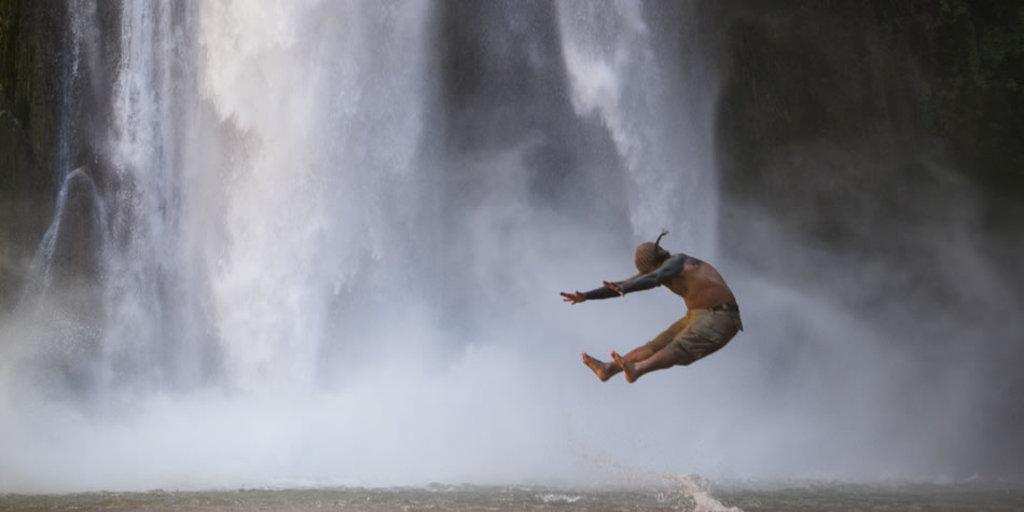What is happening to the person in the image? The person is in the air in the image. What can be seen in the background of the image? There is water visible in the background of the image. What type of worm can be seen crawling on the person's back in the image? There is no worm present in the image, and the person's back is not visible. 